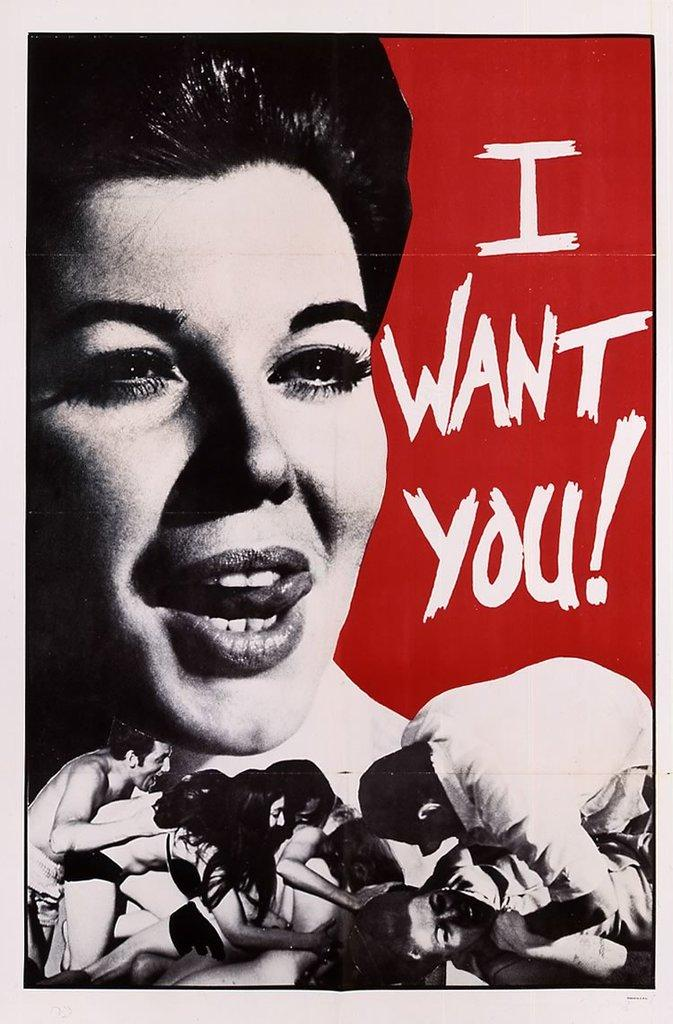<image>
Render a clear and concise summary of the photo. a poster of a women with her tongue out that says 'i want you!' 